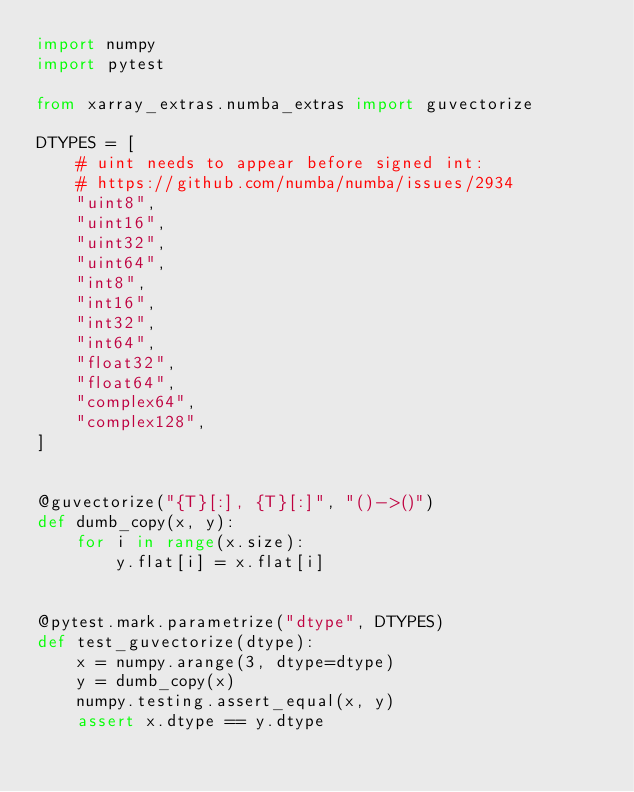Convert code to text. <code><loc_0><loc_0><loc_500><loc_500><_Python_>import numpy
import pytest

from xarray_extras.numba_extras import guvectorize

DTYPES = [
    # uint needs to appear before signed int:
    # https://github.com/numba/numba/issues/2934
    "uint8",
    "uint16",
    "uint32",
    "uint64",
    "int8",
    "int16",
    "int32",
    "int64",
    "float32",
    "float64",
    "complex64",
    "complex128",
]


@guvectorize("{T}[:], {T}[:]", "()->()")
def dumb_copy(x, y):
    for i in range(x.size):
        y.flat[i] = x.flat[i]


@pytest.mark.parametrize("dtype", DTYPES)
def test_guvectorize(dtype):
    x = numpy.arange(3, dtype=dtype)
    y = dumb_copy(x)
    numpy.testing.assert_equal(x, y)
    assert x.dtype == y.dtype
</code> 